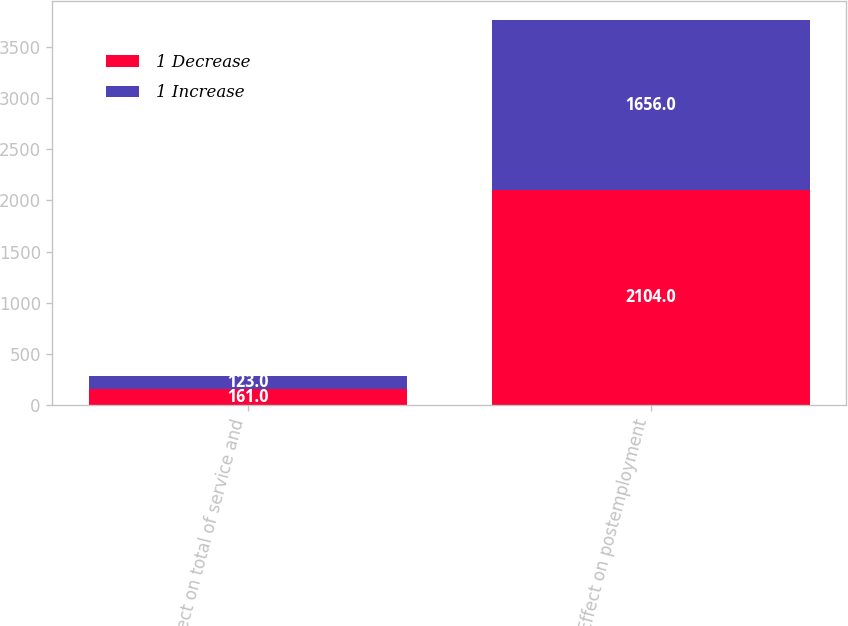Convert chart. <chart><loc_0><loc_0><loc_500><loc_500><stacked_bar_chart><ecel><fcel>Effect on total of service and<fcel>Effect on postemployment<nl><fcel>1 Decrease<fcel>161<fcel>2104<nl><fcel>1 Increase<fcel>123<fcel>1656<nl></chart> 